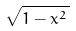<formula> <loc_0><loc_0><loc_500><loc_500>\sqrt { 1 - x ^ { 2 } \, }</formula> 